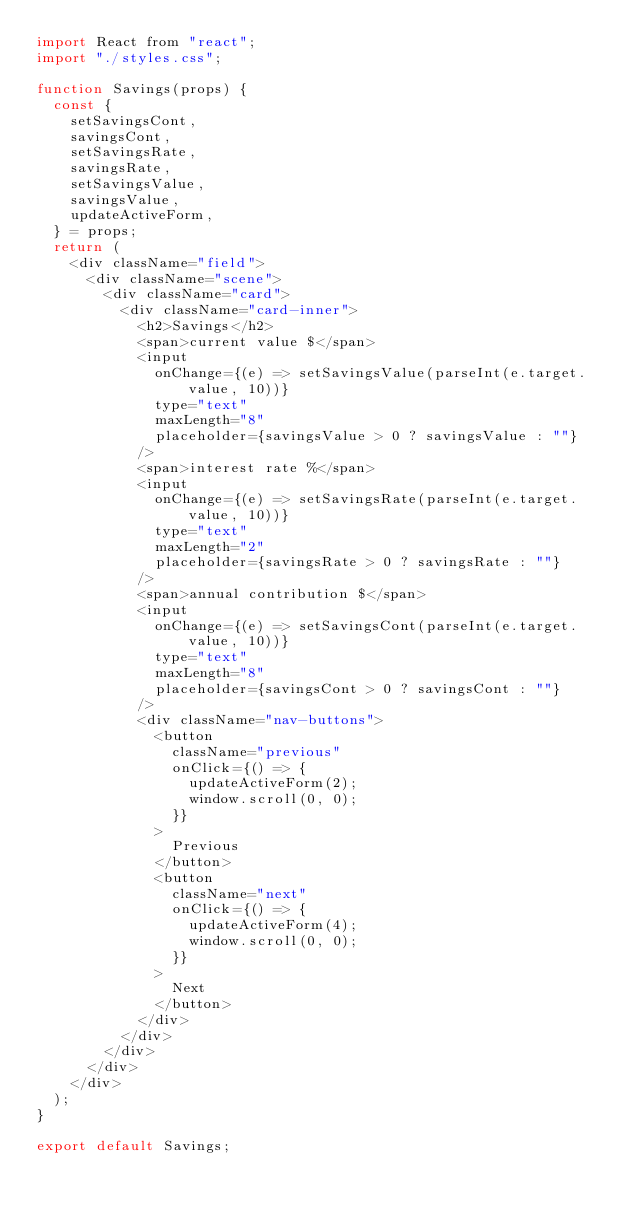<code> <loc_0><loc_0><loc_500><loc_500><_JavaScript_>import React from "react";
import "./styles.css";

function Savings(props) {
  const {
    setSavingsCont,
    savingsCont,
    setSavingsRate,
    savingsRate,
    setSavingsValue,
    savingsValue,
    updateActiveForm,
  } = props;
  return (
    <div className="field">
      <div className="scene">
        <div className="card">
          <div className="card-inner">
            <h2>Savings</h2>
            <span>current value $</span>
            <input
              onChange={(e) => setSavingsValue(parseInt(e.target.value, 10))}
              type="text"
              maxLength="8"
              placeholder={savingsValue > 0 ? savingsValue : ""}
            />
            <span>interest rate %</span>
            <input
              onChange={(e) => setSavingsRate(parseInt(e.target.value, 10))}
              type="text"
              maxLength="2"
              placeholder={savingsRate > 0 ? savingsRate : ""}
            />
            <span>annual contribution $</span>
            <input
              onChange={(e) => setSavingsCont(parseInt(e.target.value, 10))}
              type="text"
              maxLength="8"
              placeholder={savingsCont > 0 ? savingsCont : ""}
            />
            <div className="nav-buttons">
              <button
                className="previous"
                onClick={() => {
                  updateActiveForm(2);
                  window.scroll(0, 0);
                }}
              >
                Previous
              </button>
              <button
                className="next"
                onClick={() => {
                  updateActiveForm(4);
                  window.scroll(0, 0);
                }}
              >
                Next
              </button>
            </div>
          </div>
        </div>
      </div>
    </div>
  );
}

export default Savings;
</code> 